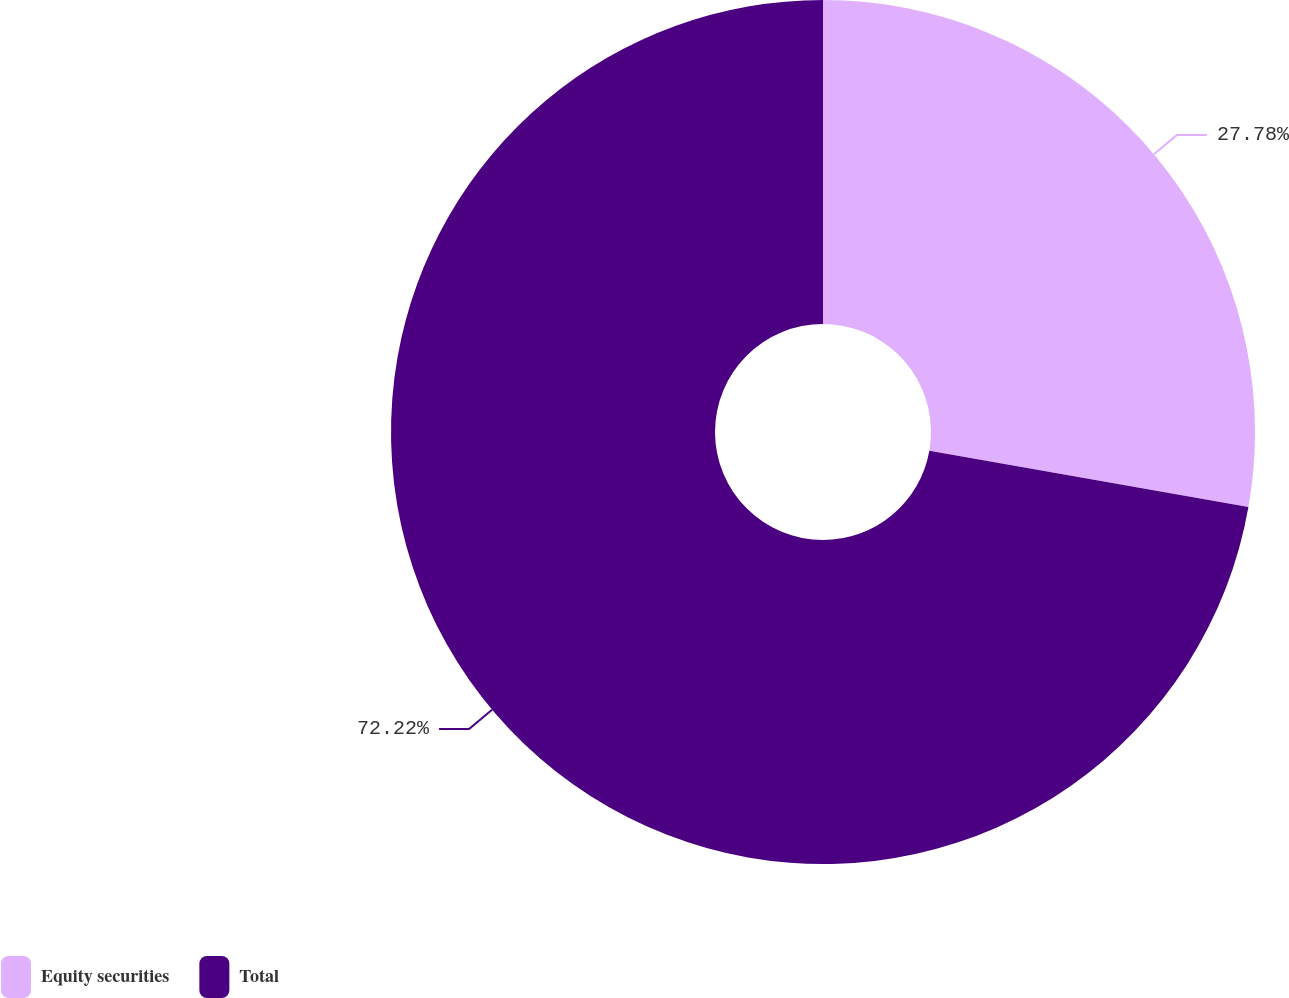Convert chart. <chart><loc_0><loc_0><loc_500><loc_500><pie_chart><fcel>Equity securities<fcel>Total<nl><fcel>27.78%<fcel>72.22%<nl></chart> 